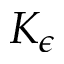Convert formula to latex. <formula><loc_0><loc_0><loc_500><loc_500>K _ { \epsilon }</formula> 